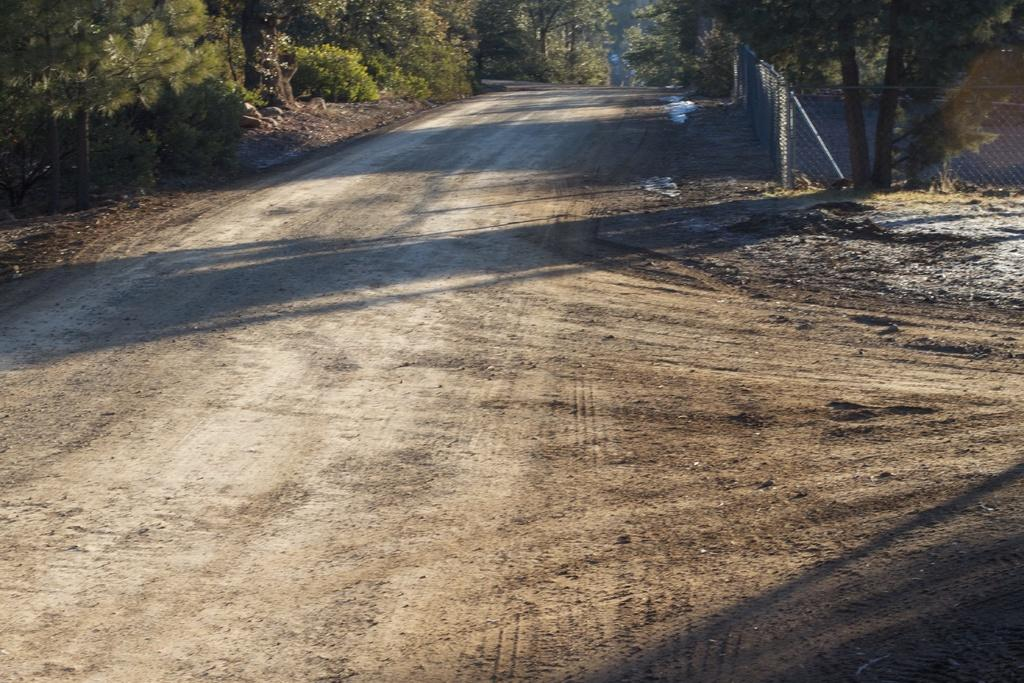What type of vegetation is visible at the top of the image? There are trees at the top of the image. What object can be seen in the image that resembles a net or grid? There is a mesh in the image. What can be seen in the background of the image? There is a ground visible in the background of the image. What type of furniture can be seen in the image? There is no furniture present in the image. Can you describe the horn that is being played by the goose in the image? There is no goose or horn present in the image. 